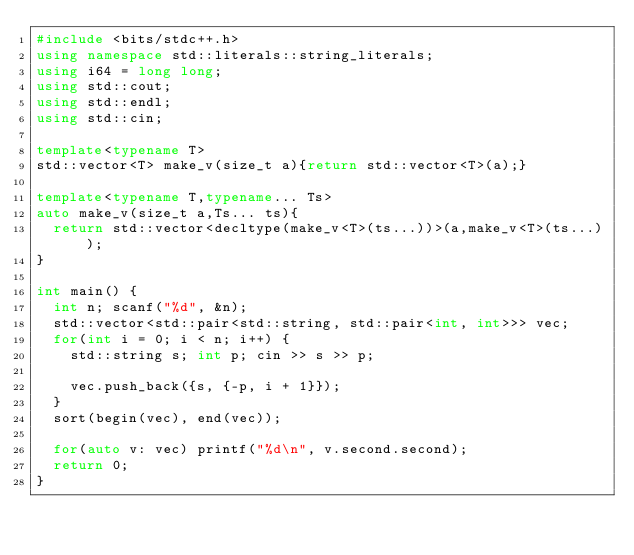<code> <loc_0><loc_0><loc_500><loc_500><_C++_>#include <bits/stdc++.h>
using namespace std::literals::string_literals;
using i64 = long long;
using std::cout;
using std::endl;
using std::cin;

template<typename T>
std::vector<T> make_v(size_t a){return std::vector<T>(a);}

template<typename T,typename... Ts>
auto make_v(size_t a,Ts... ts){
  return std::vector<decltype(make_v<T>(ts...))>(a,make_v<T>(ts...));
}

int main() {
	int n; scanf("%d", &n);
	std::vector<std::pair<std::string, std::pair<int, int>>> vec;
	for(int i = 0; i < n; i++) {
		std::string s; int p; cin >> s >> p;
		
		vec.push_back({s, {-p, i + 1}});
	}
	sort(begin(vec), end(vec));
	
	for(auto v: vec) printf("%d\n", v.second.second);
	return 0;
}
</code> 